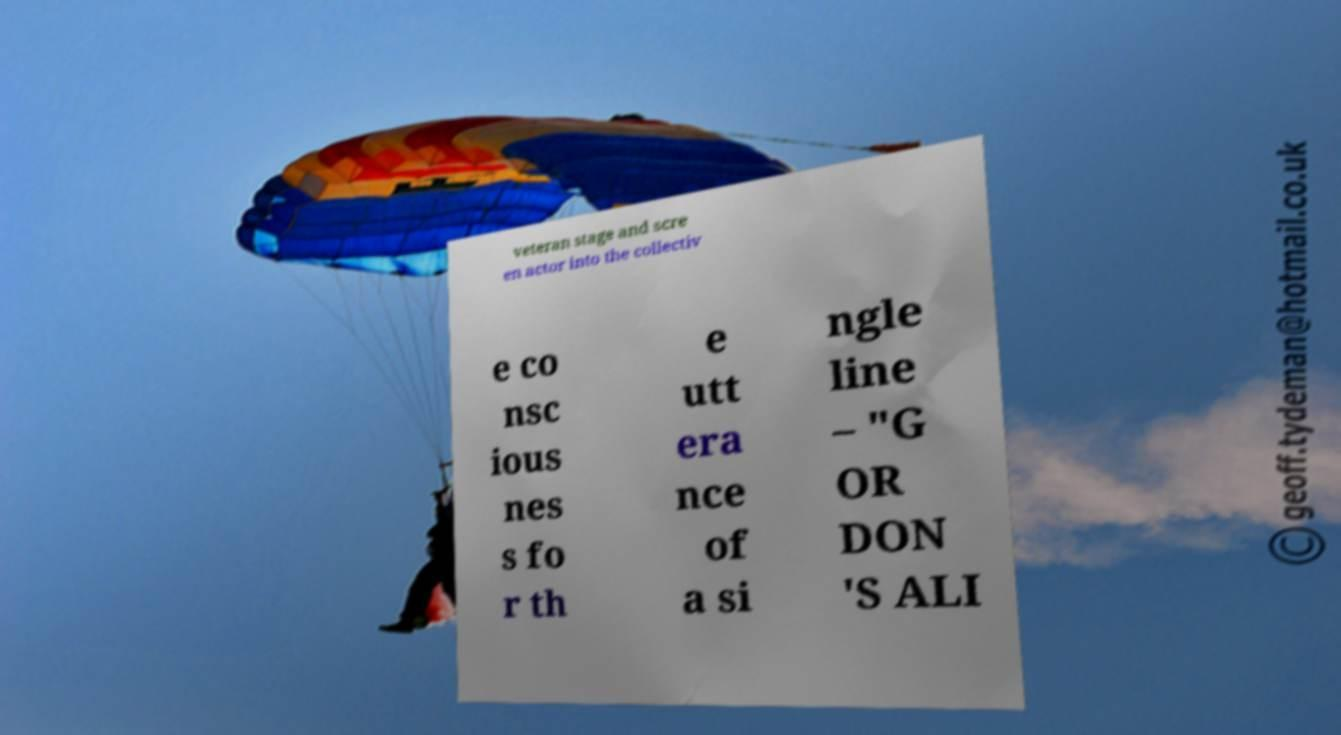Please identify and transcribe the text found in this image. veteran stage and scre en actor into the collectiv e co nsc ious nes s fo r th e utt era nce of a si ngle line – "G OR DON 'S ALI 